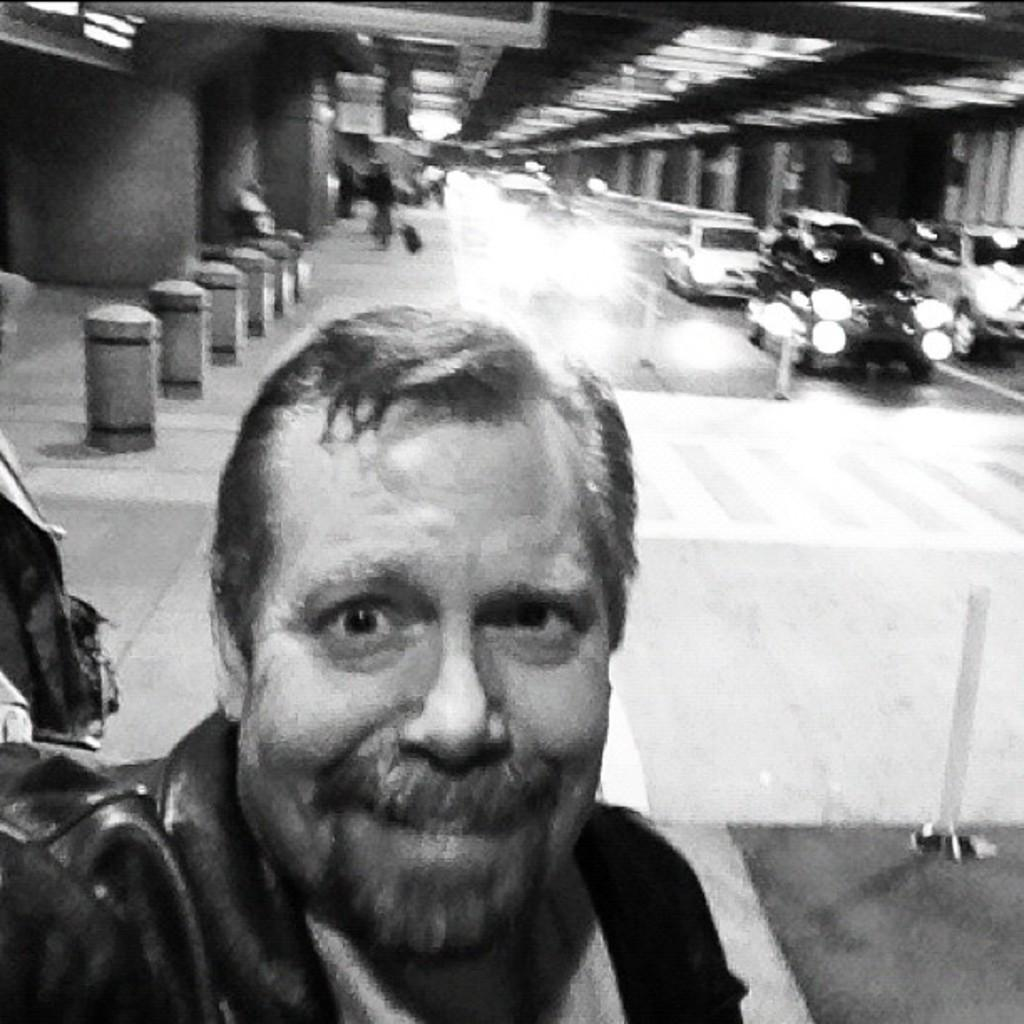What is the color scheme of the image? The image is black and white. Can you describe the main subject in the image? There is a person in the image. What can be seen in the background of the image? There are vehicles, small poles, and lights in the background of the image. How would you describe the background of the image? The background is blurred. Reasoning: Let' Let's think step by step in order to produce the conversation. We start by identifying the color scheme of the image, which is black and white. Then, we focus on the main subject, which is a person. Next, we describe the conversation expands to include details about the background, such as the presence of vehicles, small poles, and lights. Finally, we describe the appearance of the background, which is blurred. Absurd Question/Answer: What type of twig is being used by the person in the image? There is no twig present in the image. What is the condition of the plastic in the image? There is no plastic present in the image. 